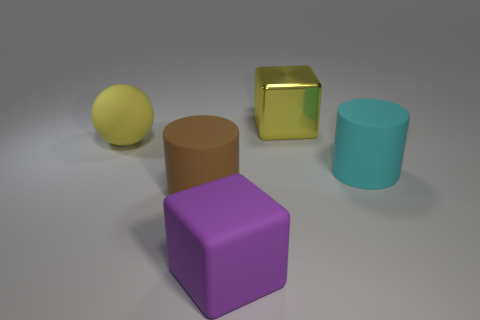Subtract 1 yellow cubes. How many objects are left? 4 Subtract all cylinders. How many objects are left? 3 Subtract 1 cylinders. How many cylinders are left? 1 Subtract all red spheres. Subtract all yellow cylinders. How many spheres are left? 1 Subtract all brown balls. How many gray cylinders are left? 0 Subtract all small matte cylinders. Subtract all yellow shiny things. How many objects are left? 4 Add 4 matte cylinders. How many matte cylinders are left? 6 Add 5 big yellow spheres. How many big yellow spheres exist? 6 Add 5 red cylinders. How many objects exist? 10 Subtract all purple blocks. How many blocks are left? 1 